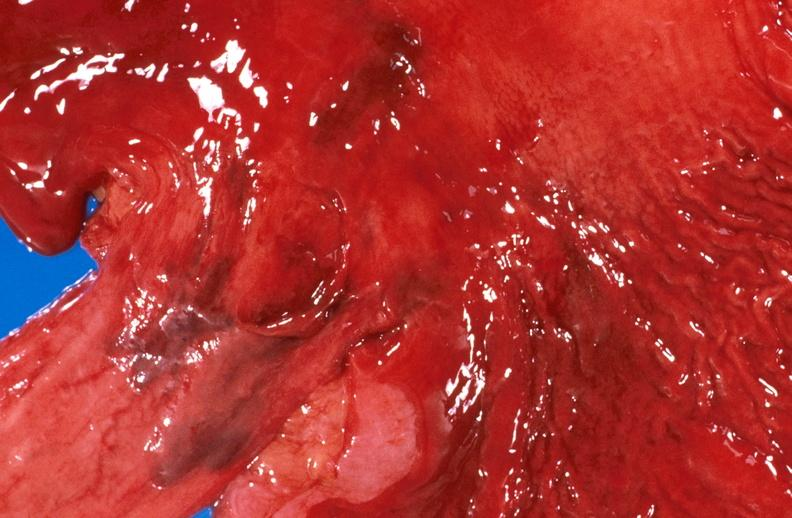what is present?
Answer the question using a single word or phrase. Gastrointestinal 